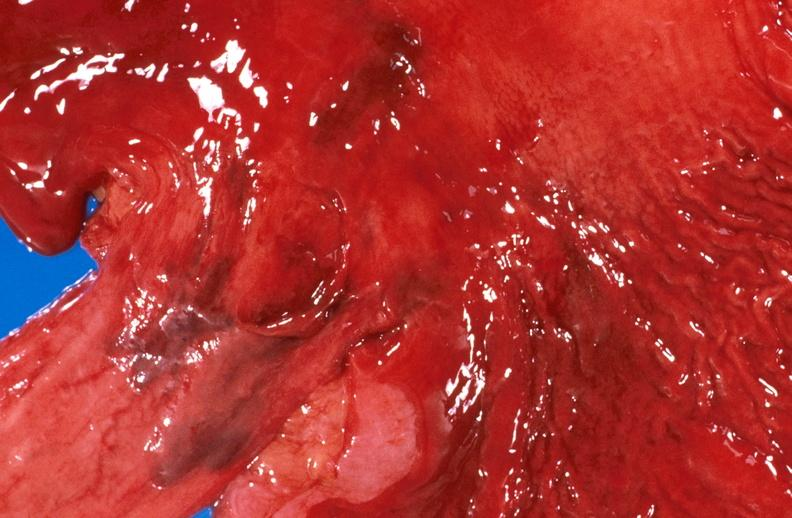what is present?
Answer the question using a single word or phrase. Gastrointestinal 